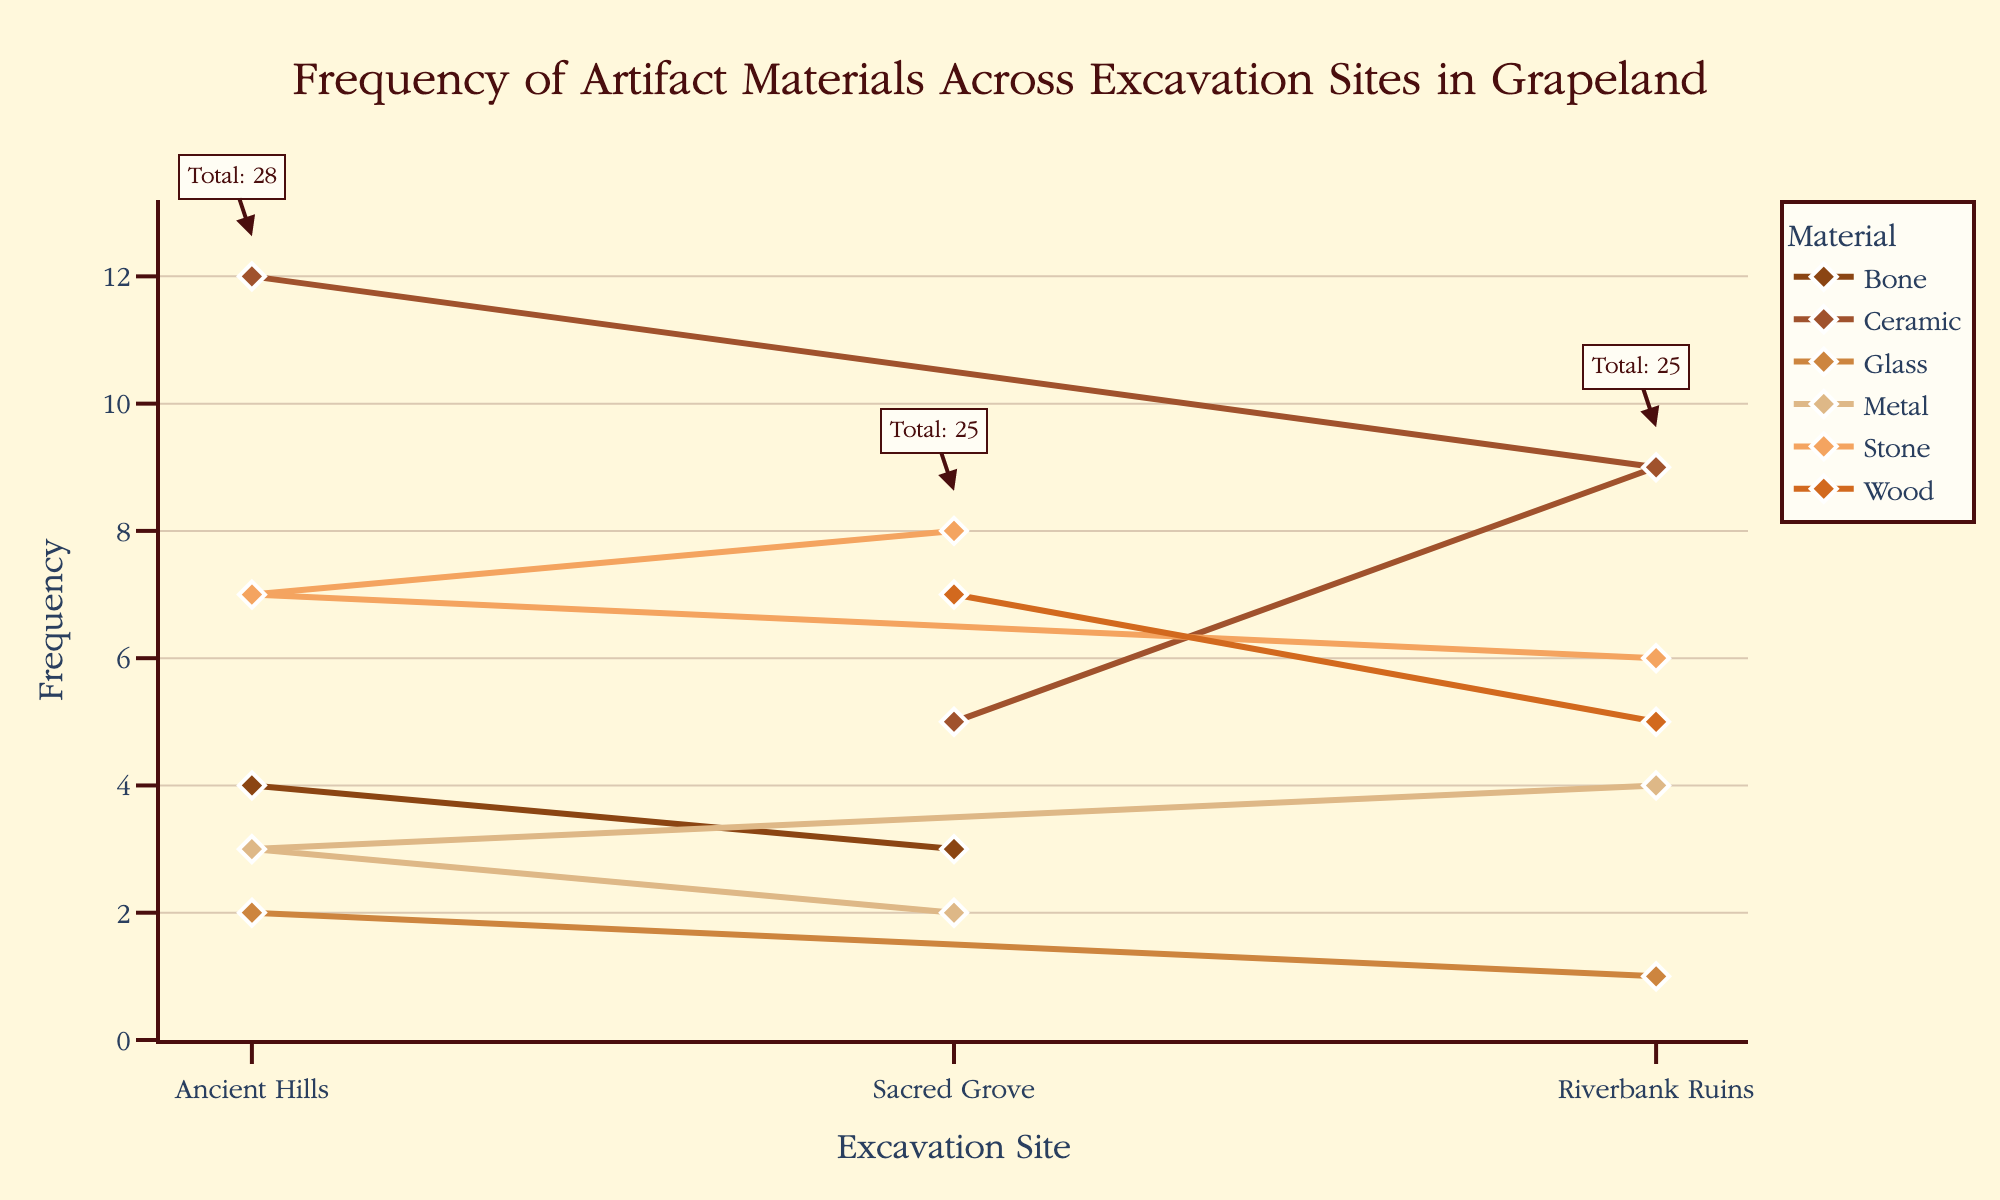What is the title of the plot? The title of the plot is found at the top of the figure. It describes the main subject of the visualization.
Answer: Frequency of Artifact Materials Across Excavation Sites in Grapeland What is the frequency of Ceramic artifacts found at Ancient Hills? Locate the 'Ceramic' line and find its data point corresponding to 'Ancient Hills.' The y-axis value here represents the frequency.
Answer: 12 Which excavation site has the highest total artifacts? By observing the annotations on the plot, sum each site's artifacts. The site with the largest sum has the highest total artifacts.
Answer: Ancient Hills How many more Stone artifacts were found at Sacred Grove compared to Riverbank Ruins? Find the frequency of Stone artifacts at Sacred Grove and Riverbank Ruins and subtract the latter from the former.
Answer: 2 Which material has the lowest total frequency across all sites? Sum the frequencies for each material across all sites. The material with the smallest total is the answer.
Answer: Glass Are there any materials found at only one site? Check each material's data points in the figure. If only one site has data for a material, it is found at only one site.
Answer: Yes, Bone and Glass artifacts Which material shows the most uniform distribution of frequency across the sites? Compare the variance of frequencies of each material. The material with the least variance is most uniformly distributed.
Answer: Stone What is the average frequency of artifacts found at Riverbank Ruins? Sum all frequencies at Riverbank Ruins and divide by the number of different materials found at the site.
Answer: (9+6+4+5+1)/5 = 5 How does the frequency of Wood artifacts at Sacred Grove compare to that at Riverbank Ruins? Compare the y-axis values for Wood artifacts at 'Sacred Grove' and 'Riverbank Ruins.'
Answer: Sacred Grove has 2 more than Riverbank Ruins Which material's frequency decreases the most from one site to another? Compare the maximum frequency decrease between sites for each material.
Answer: Ceramic from Ancient Hills to Sacred Grove 